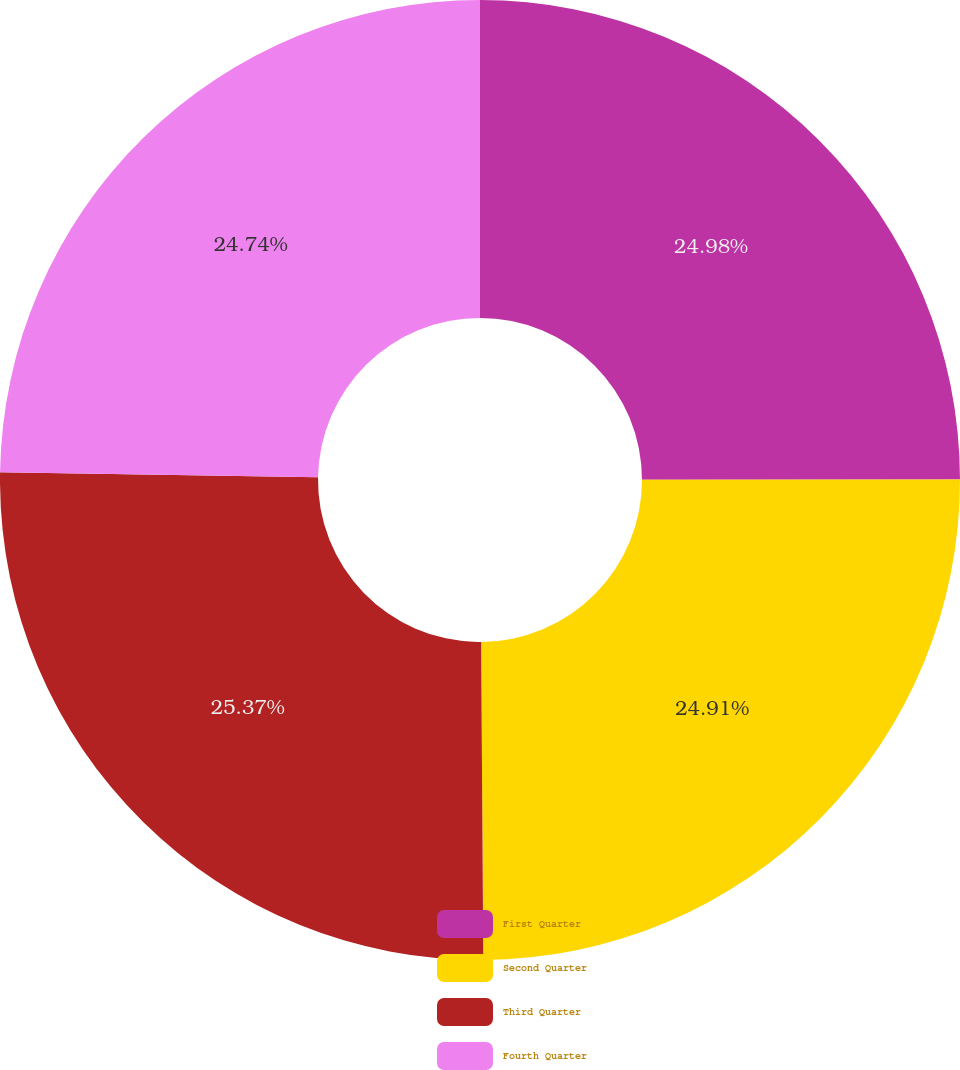Convert chart to OTSL. <chart><loc_0><loc_0><loc_500><loc_500><pie_chart><fcel>First Quarter<fcel>Second Quarter<fcel>Third Quarter<fcel>Fourth Quarter<nl><fcel>24.98%<fcel>24.91%<fcel>25.37%<fcel>24.74%<nl></chart> 